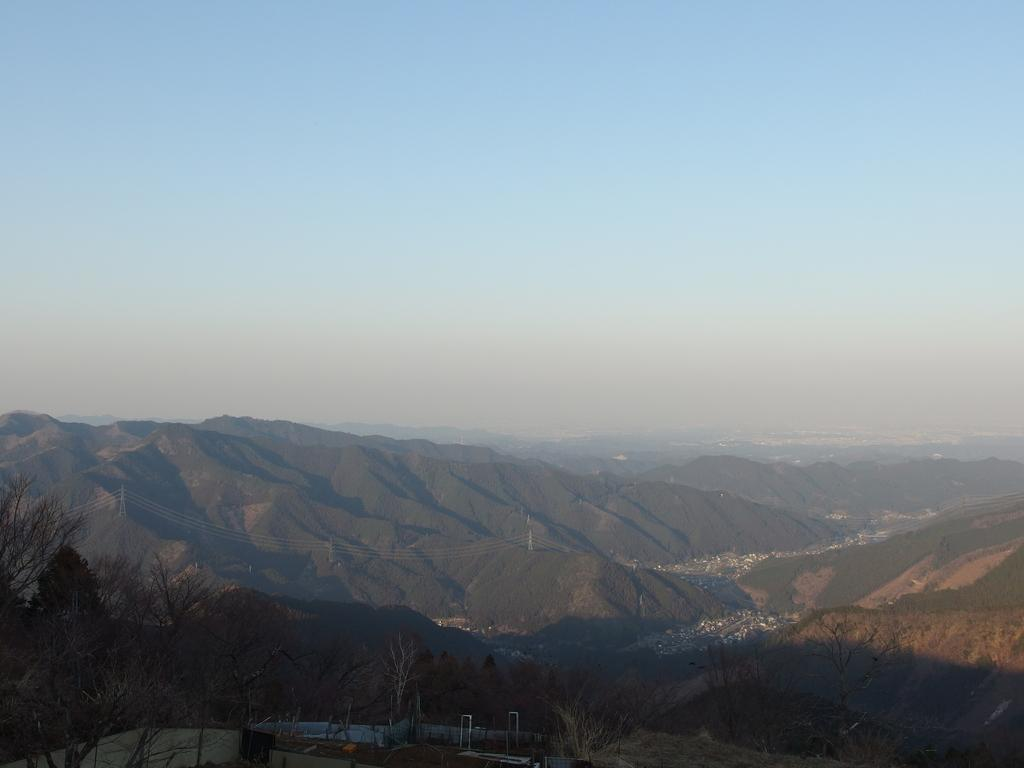What type of vegetation is present in the image? There are dry trees in the image. What geographical feature can be seen in the background? There are mountains in the image. What color is the sky in the image? The sky is blue in the image. Where are the flowers located in the image? There are no flowers present in the image. What type of structure can be seen in the image, such as an arch? There is no structure like an arch present in the image. 